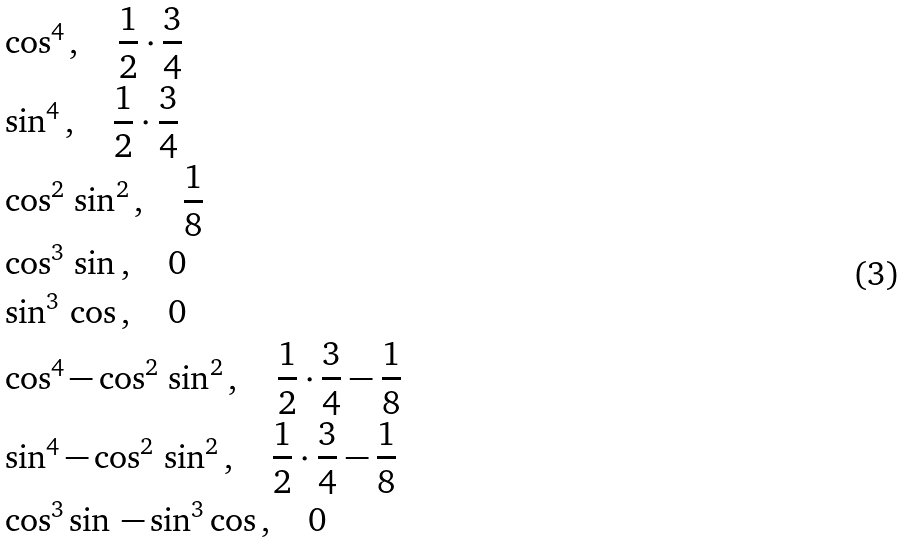Convert formula to latex. <formula><loc_0><loc_0><loc_500><loc_500>& \cos ^ { 4 } \, , \quad \frac { 1 } { 2 } \cdot \frac { 3 } { 4 } \\ & \sin ^ { 4 } \, , \quad \frac { 1 } { 2 } \cdot \frac { 3 } { 4 } \\ & \cos ^ { 2 } \, \sin ^ { 2 } \, , \quad \frac { 1 } { 8 } \\ & \cos ^ { 3 } \, \sin \, , \quad 0 \\ & \sin ^ { 3 } \, \cos \, , \quad 0 \\ & \cos ^ { 4 } - \cos ^ { 2 } \, \sin ^ { 2 } \, , \quad \frac { 1 } { 2 } \cdot \frac { 3 } { 4 } - \frac { 1 } { 8 } \\ & \sin ^ { 4 } - \cos ^ { 2 } \, \sin ^ { 2 } \, , \quad \frac { 1 } { 2 } \cdot \frac { 3 } { 4 } - \frac { 1 } { 8 } \\ & \cos ^ { 3 } \sin \, - \sin ^ { 3 } \cos \, , \quad 0 \\</formula> 